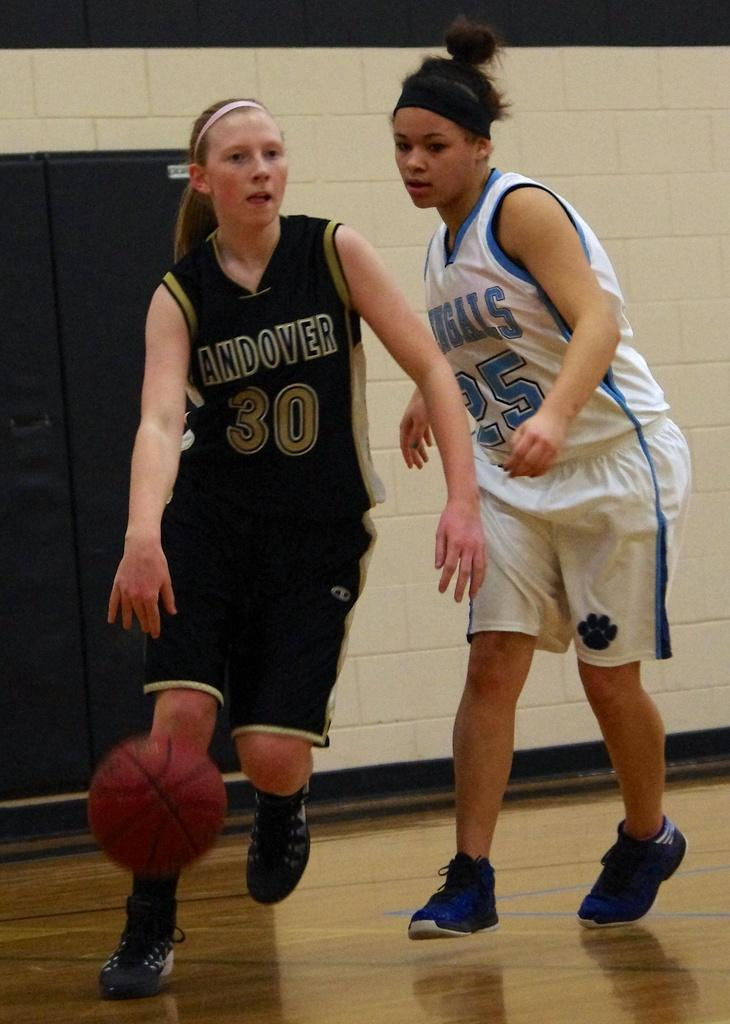<image>
Relay a brief, clear account of the picture shown. The basketball player with the ball is from Andover. 